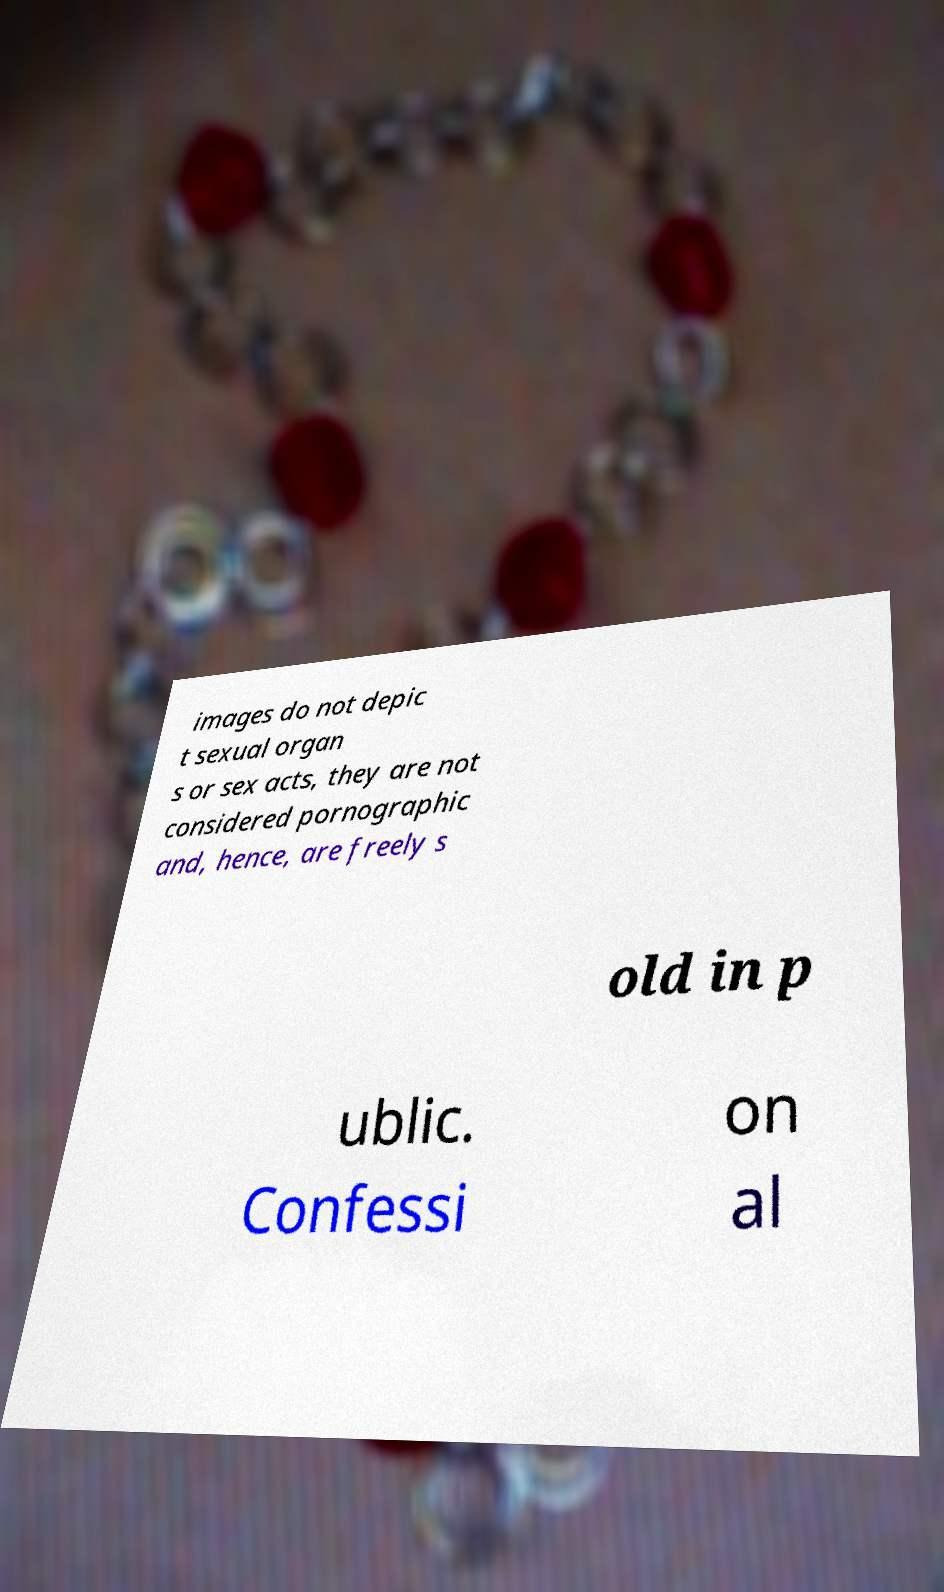Please identify and transcribe the text found in this image. images do not depic t sexual organ s or sex acts, they are not considered pornographic and, hence, are freely s old in p ublic. Confessi on al 